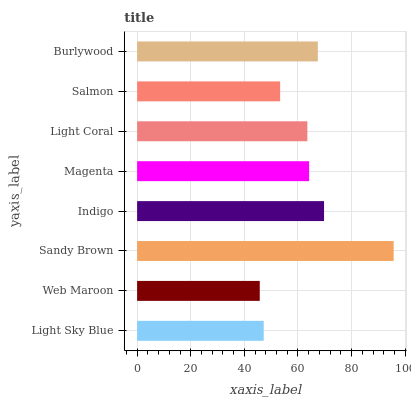Is Web Maroon the minimum?
Answer yes or no. Yes. Is Sandy Brown the maximum?
Answer yes or no. Yes. Is Sandy Brown the minimum?
Answer yes or no. No. Is Web Maroon the maximum?
Answer yes or no. No. Is Sandy Brown greater than Web Maroon?
Answer yes or no. Yes. Is Web Maroon less than Sandy Brown?
Answer yes or no. Yes. Is Web Maroon greater than Sandy Brown?
Answer yes or no. No. Is Sandy Brown less than Web Maroon?
Answer yes or no. No. Is Magenta the high median?
Answer yes or no. Yes. Is Light Coral the low median?
Answer yes or no. Yes. Is Salmon the high median?
Answer yes or no. No. Is Salmon the low median?
Answer yes or no. No. 